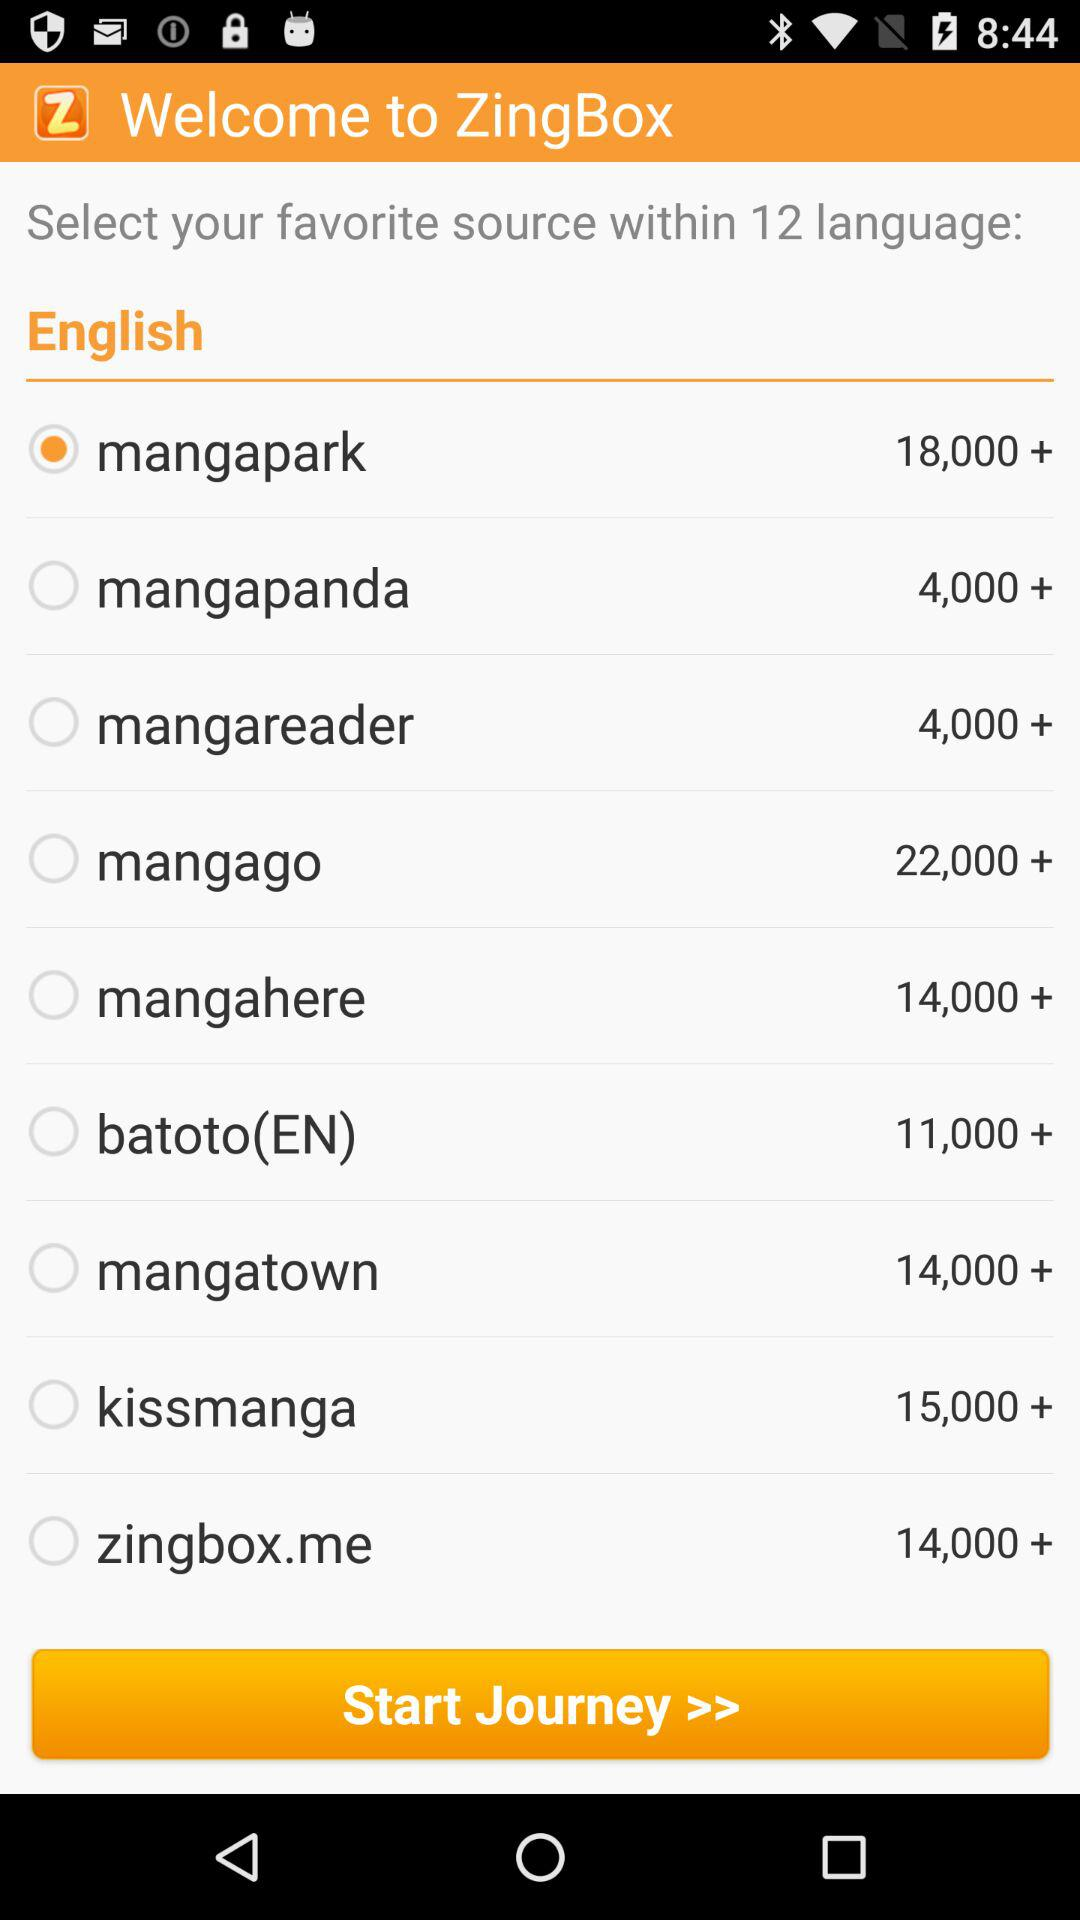What is the name of the application? The name of the application is "ZingBox". 